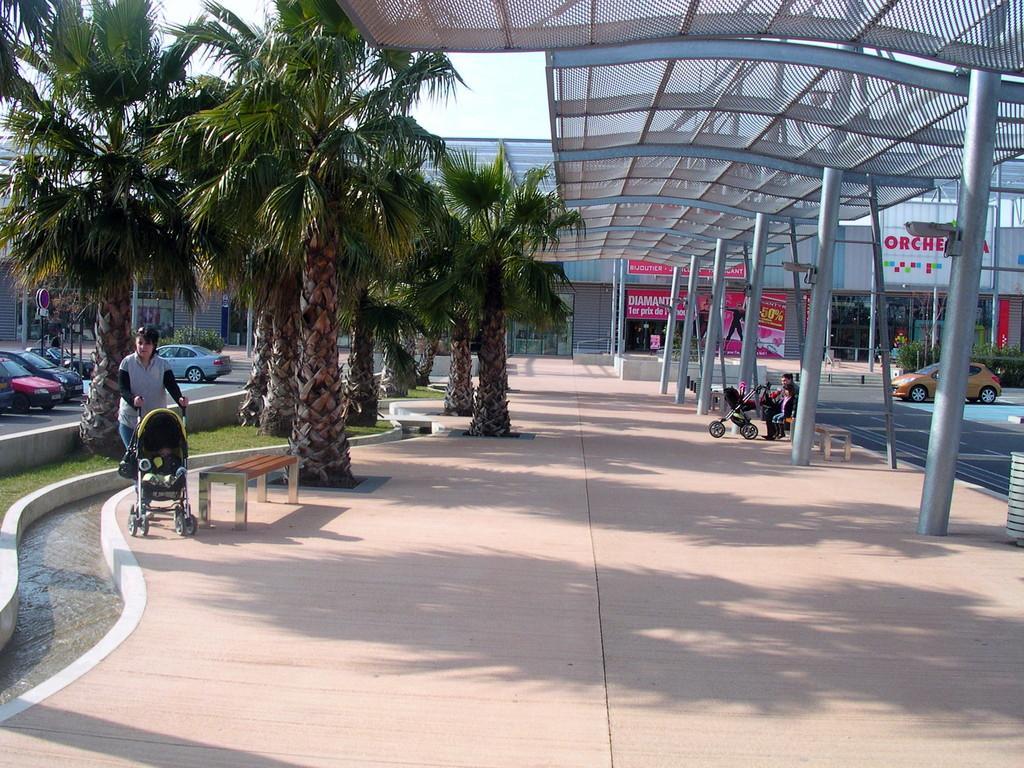Can you describe this image briefly? In this picture there is a person standing and holding the baby traveler and there are two persons sitting on the bench and there is a baby traveler. There are buildings, trees and there are vehicles and there are boards and there is a hoarding. At the top there is sky. At the bottom there is a pavement and there is grass and water. 